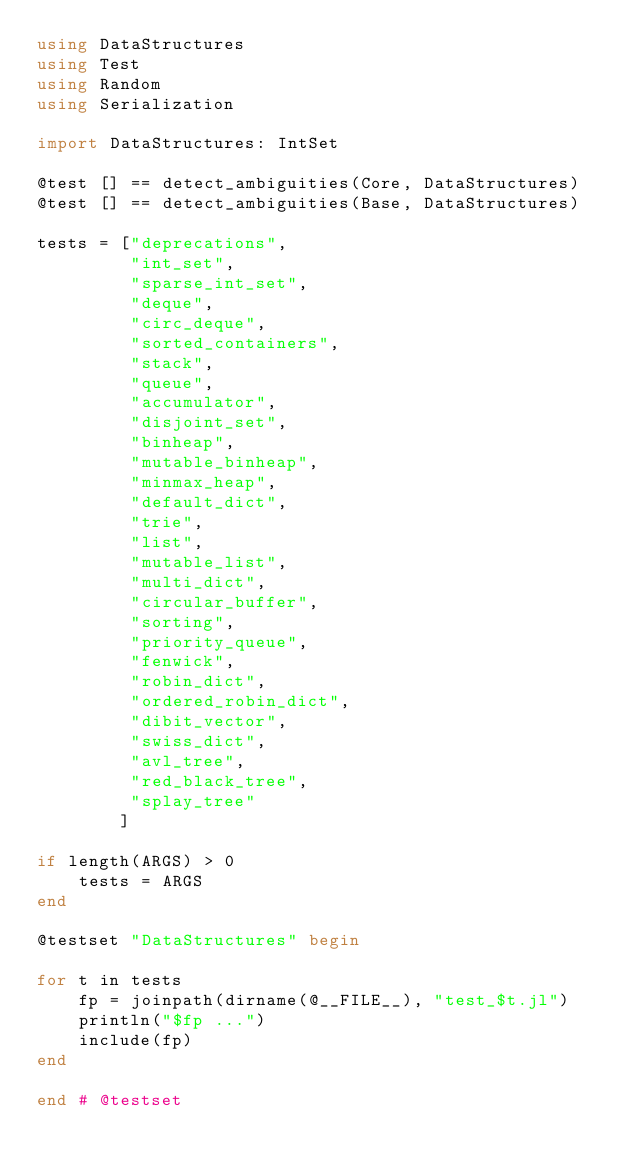Convert code to text. <code><loc_0><loc_0><loc_500><loc_500><_Julia_>using DataStructures
using Test
using Random
using Serialization

import DataStructures: IntSet

@test [] == detect_ambiguities(Core, DataStructures)
@test [] == detect_ambiguities(Base, DataStructures)

tests = ["deprecations",
         "int_set",
         "sparse_int_set",
         "deque",
         "circ_deque",
         "sorted_containers",
         "stack",
         "queue",
         "accumulator",
         "disjoint_set",
         "binheap",
         "mutable_binheap",
         "minmax_heap",
         "default_dict",
         "trie",
         "list",
         "mutable_list",
         "multi_dict",
         "circular_buffer",
         "sorting",
         "priority_queue",
         "fenwick",
         "robin_dict",
         "ordered_robin_dict",
         "dibit_vector",
         "swiss_dict",
         "avl_tree",
         "red_black_tree",
         "splay_tree"
        ]

if length(ARGS) > 0
    tests = ARGS
end

@testset "DataStructures" begin

for t in tests
    fp = joinpath(dirname(@__FILE__), "test_$t.jl")
    println("$fp ...")
    include(fp)
end

end # @testset
</code> 